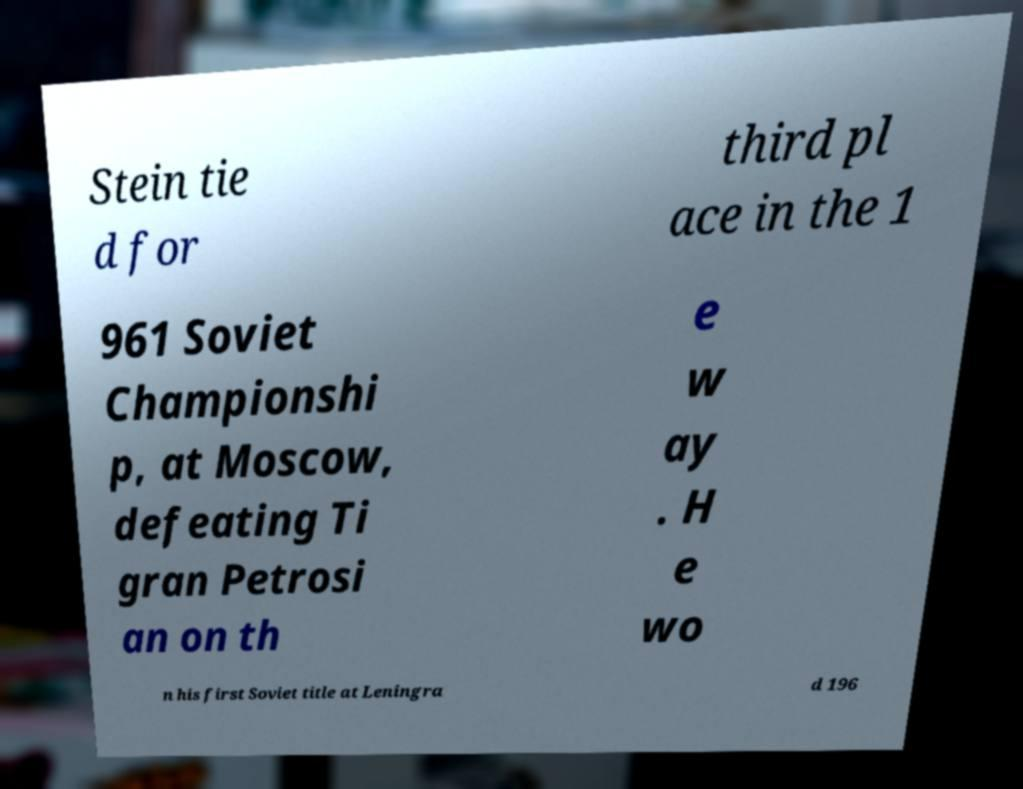Can you accurately transcribe the text from the provided image for me? Stein tie d for third pl ace in the 1 961 Soviet Championshi p, at Moscow, defeating Ti gran Petrosi an on th e w ay . H e wo n his first Soviet title at Leningra d 196 